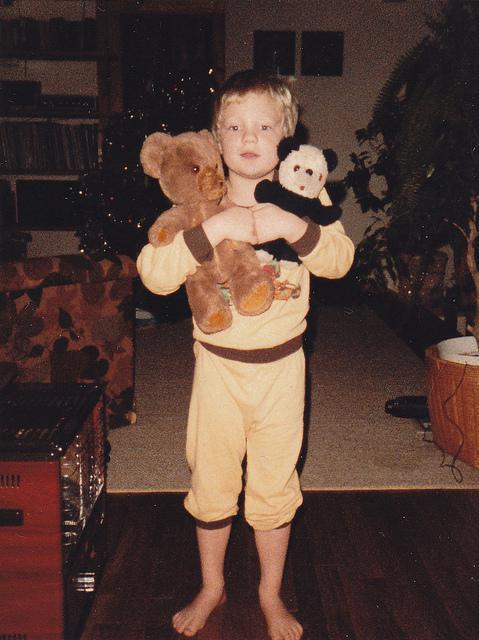How many teddy bears can be seen?
Give a very brief answer. 2. 